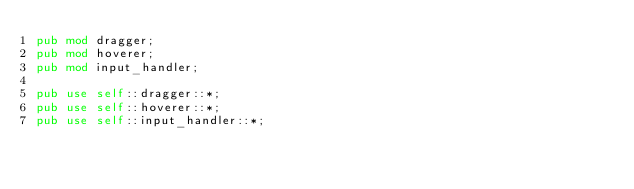Convert code to text. <code><loc_0><loc_0><loc_500><loc_500><_Rust_>pub mod dragger;
pub mod hoverer;
pub mod input_handler;

pub use self::dragger::*;
pub use self::hoverer::*;
pub use self::input_handler::*;
</code> 